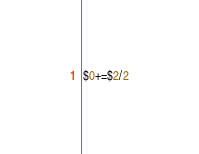Convert code to text. <code><loc_0><loc_0><loc_500><loc_500><_Awk_>$0+=$2/2</code> 